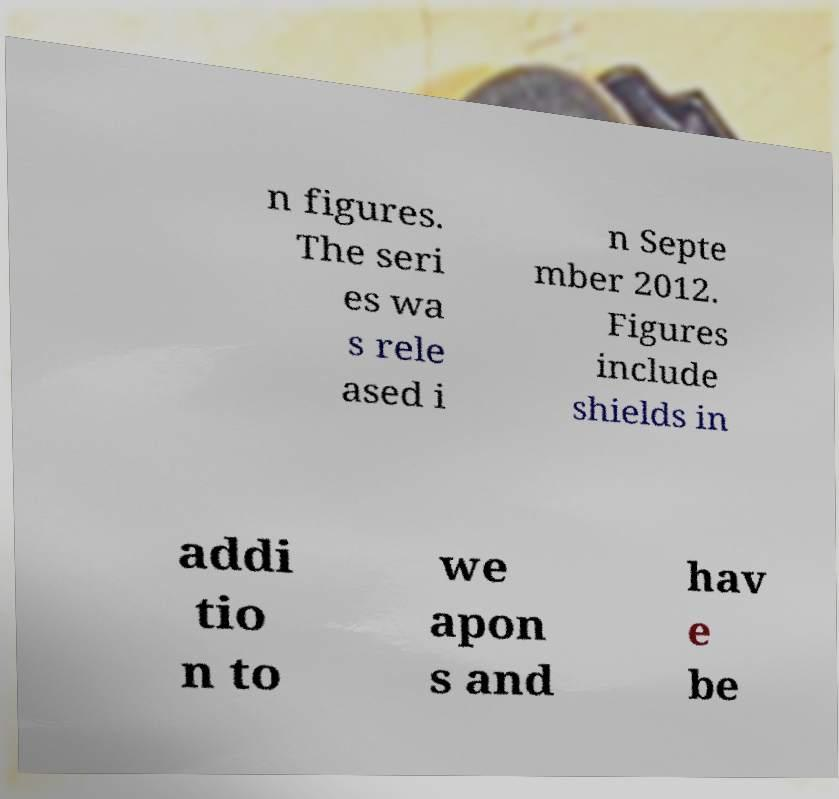I need the written content from this picture converted into text. Can you do that? n figures. The seri es wa s rele ased i n Septe mber 2012. Figures include shields in addi tio n to we apon s and hav e be 